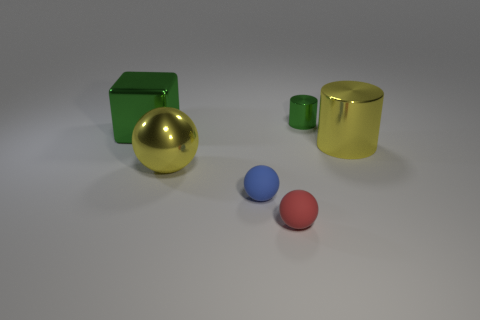Subtract all red matte spheres. How many spheres are left? 2 Subtract 1 balls. How many balls are left? 2 Add 4 large shiny objects. How many objects exist? 10 Subtract all cylinders. How many objects are left? 4 Subtract all gray blocks. Subtract all purple spheres. How many blocks are left? 1 Subtract all big green matte objects. Subtract all rubber things. How many objects are left? 4 Add 3 yellow metal things. How many yellow metal things are left? 5 Add 6 big green metal blocks. How many big green metal blocks exist? 7 Subtract 0 yellow blocks. How many objects are left? 6 